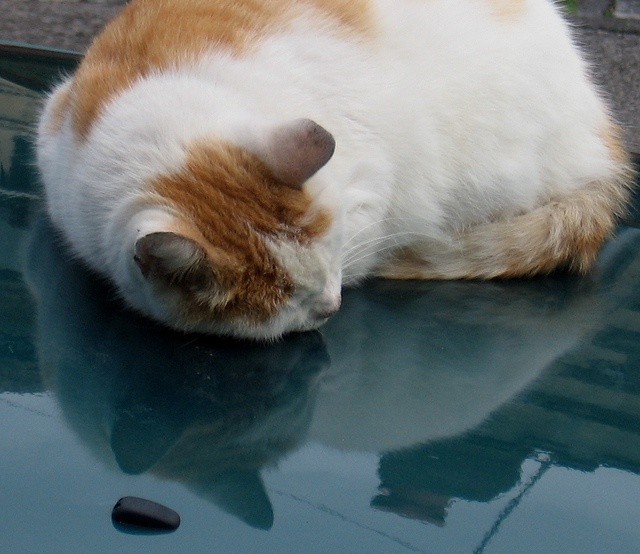Describe the objects in this image and their specific colors. I can see car in gray, black, teal, and purple tones and cat in gray, lightgray, and darkgray tones in this image. 